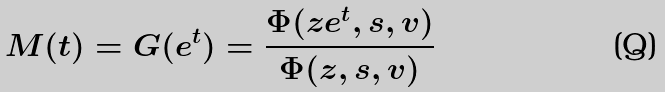Convert formula to latex. <formula><loc_0><loc_0><loc_500><loc_500>M ( t ) = G ( e ^ { t } ) = \frac { \Phi ( z e ^ { t } , s , v ) } { \Phi ( z , s , v ) }</formula> 